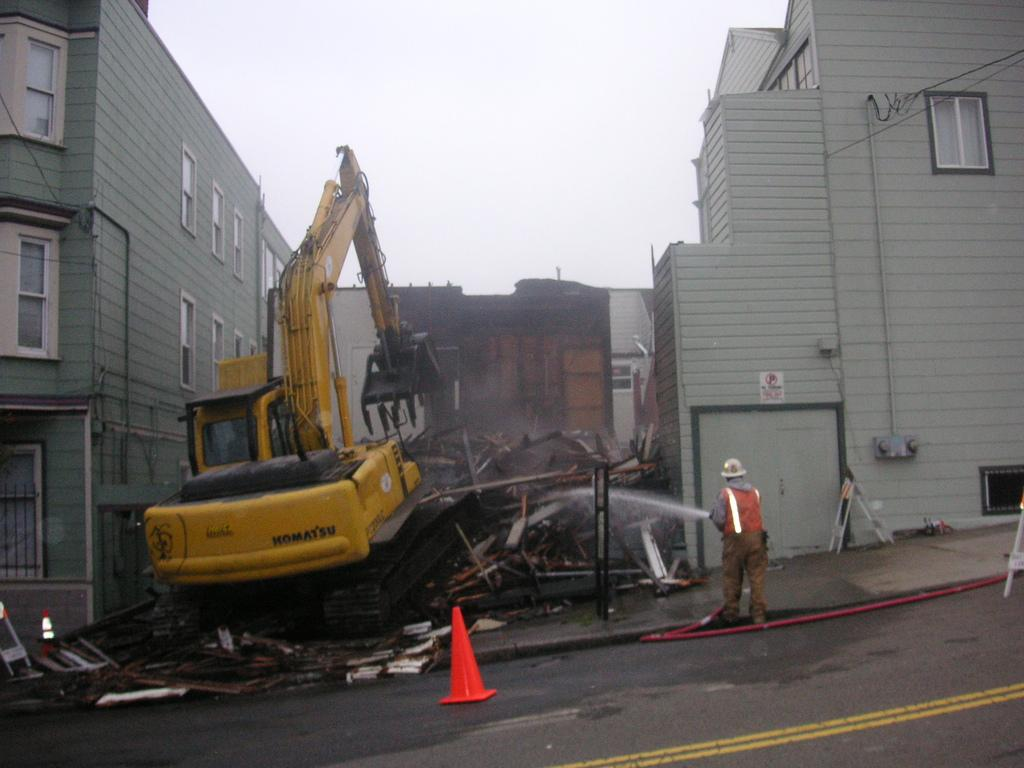What type of structures can be seen in the image? There are buildings in the image. What is the person in the image holding? The person is holding a pipe in the image. What can be observed about the condition of some objects in the image? There are crashed objects in the image. What substance is visible in the image? Procaine is visible in the image. What is present on the road in the image? A divider block is visible on the road in the image. What is visible at the top of the image? The sky is visible at the top of the image. What type of meat is being weighed in the image? There is no meat present in the image. What is the size of the divider block on the road in the image? The size of the divider block is not mentioned in the facts provided, so it cannot be determined from the image. 